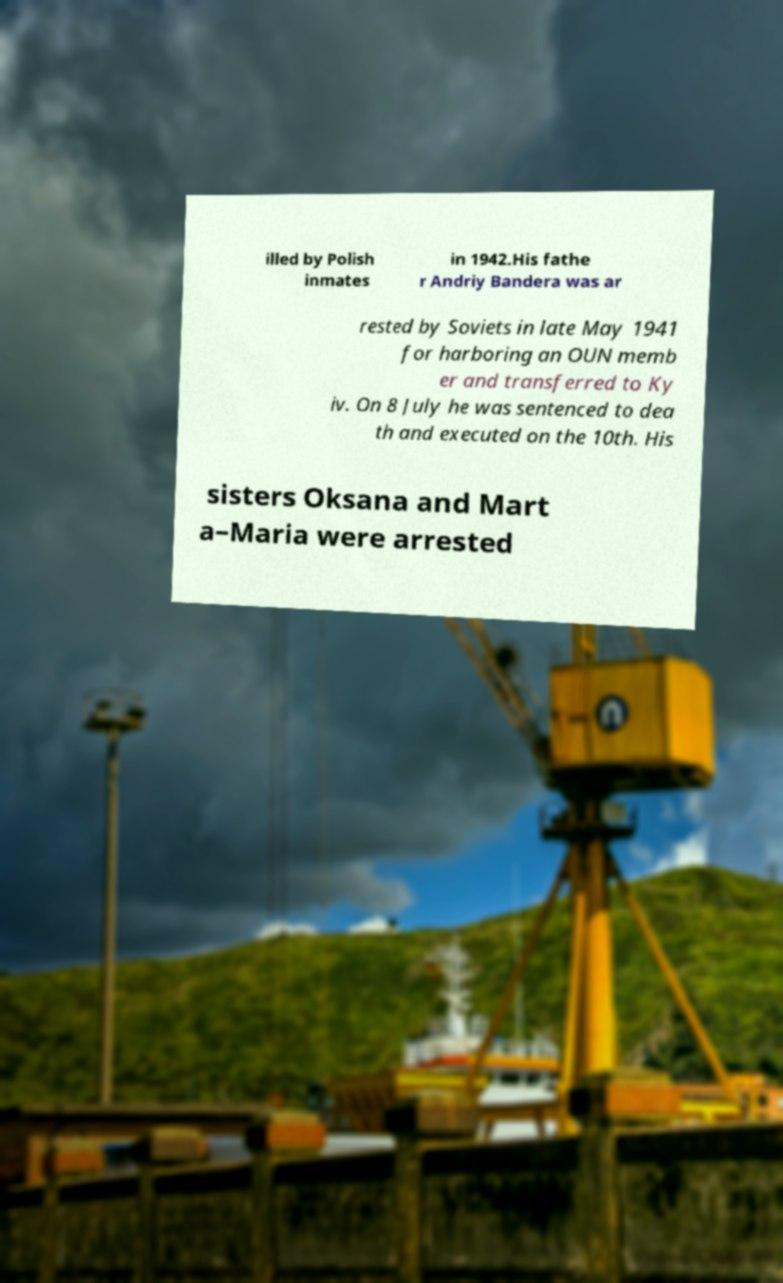Could you assist in decoding the text presented in this image and type it out clearly? illed by Polish inmates in 1942.His fathe r Andriy Bandera was ar rested by Soviets in late May 1941 for harboring an OUN memb er and transferred to Ky iv. On 8 July he was sentenced to dea th and executed on the 10th. His sisters Oksana and Mart a–Maria were arrested 